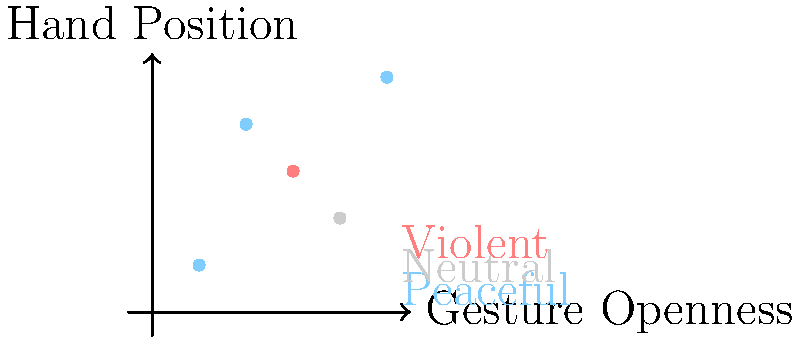In the context of interfaith gatherings, which combination of gesture openness and hand position is most likely to be classified as a peaceful gesture by a machine learning model trained to detect such gestures? To answer this question, we need to analyze the graph and understand the relationship between gesture openness and hand position in the context of peaceful gestures. Let's break it down step-by-step:

1. The x-axis represents "Gesture Openness," which likely refers to how open and welcoming a person's body language appears.
2. The y-axis represents "Hand Position," which could indicate the height or placement of hands relative to the body.
3. The graph uses color-coding to classify gestures:
   - Blue points represent peaceful gestures
   - Gray points represent neutral gestures
   - Red points represent violent gestures

4. Analyzing the blue (peaceful) points:
   a. (1,1): Low openness, low hand position
   b. (2,4): Moderate openness, high hand position
   c. (5,5): High openness, high hand position

5. The point at (5,5) represents the highest values for both gesture openness and hand position, and it is classified as peaceful.

6. In interfaith gatherings, gestures that are more open and with hands positioned higher (such as raised in greeting or prayer) are typically associated with peaceful intentions.

Therefore, the combination of high gesture openness and high hand position (5,5) is most likely to be classified as a peaceful gesture by a machine learning model trained for this purpose.
Answer: High gesture openness and high hand position (5,5) 